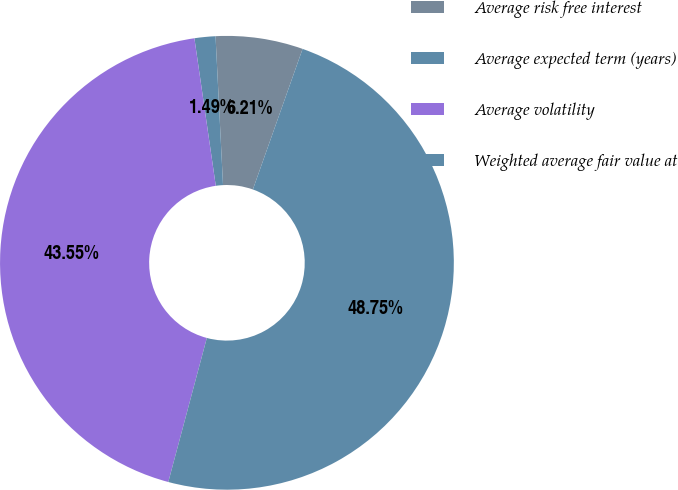Convert chart. <chart><loc_0><loc_0><loc_500><loc_500><pie_chart><fcel>Average risk free interest<fcel>Average expected term (years)<fcel>Average volatility<fcel>Weighted average fair value at<nl><fcel>6.21%<fcel>1.49%<fcel>43.55%<fcel>48.75%<nl></chart> 